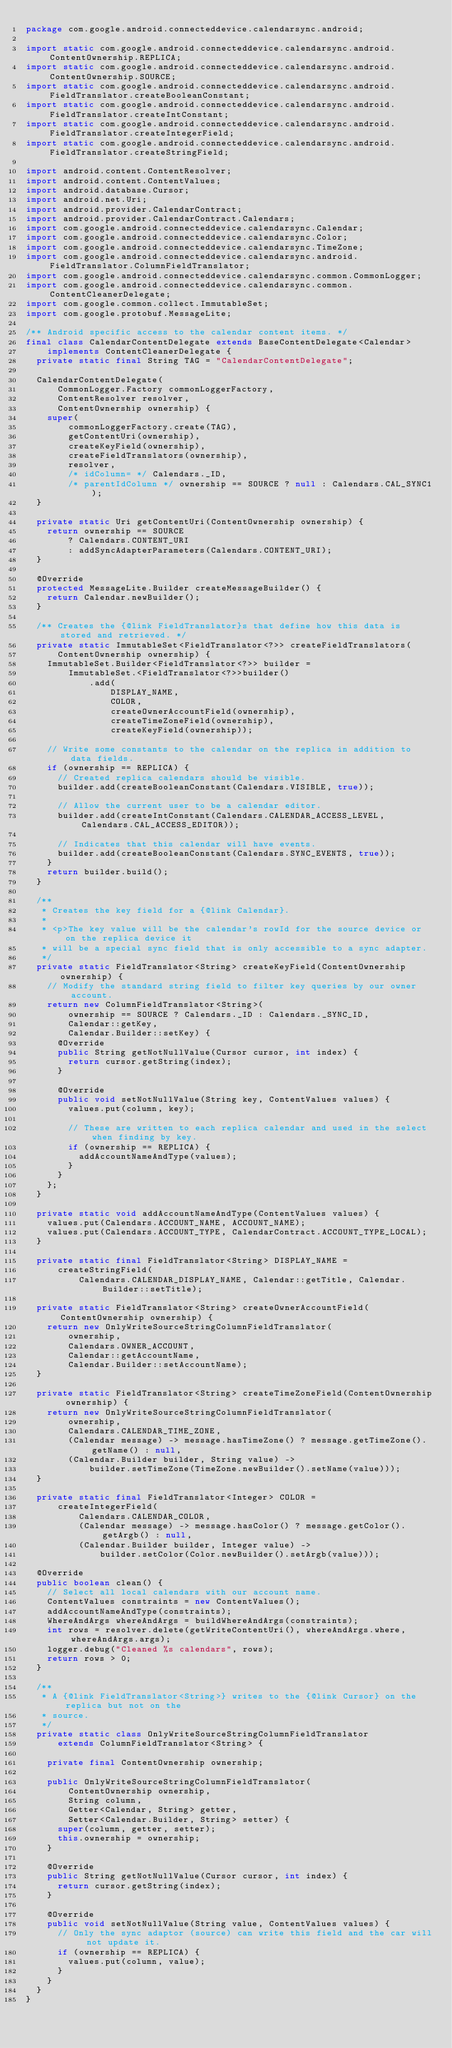Convert code to text. <code><loc_0><loc_0><loc_500><loc_500><_Java_>package com.google.android.connecteddevice.calendarsync.android;

import static com.google.android.connecteddevice.calendarsync.android.ContentOwnership.REPLICA;
import static com.google.android.connecteddevice.calendarsync.android.ContentOwnership.SOURCE;
import static com.google.android.connecteddevice.calendarsync.android.FieldTranslator.createBooleanConstant;
import static com.google.android.connecteddevice.calendarsync.android.FieldTranslator.createIntConstant;
import static com.google.android.connecteddevice.calendarsync.android.FieldTranslator.createIntegerField;
import static com.google.android.connecteddevice.calendarsync.android.FieldTranslator.createStringField;

import android.content.ContentResolver;
import android.content.ContentValues;
import android.database.Cursor;
import android.net.Uri;
import android.provider.CalendarContract;
import android.provider.CalendarContract.Calendars;
import com.google.android.connecteddevice.calendarsync.Calendar;
import com.google.android.connecteddevice.calendarsync.Color;
import com.google.android.connecteddevice.calendarsync.TimeZone;
import com.google.android.connecteddevice.calendarsync.android.FieldTranslator.ColumnFieldTranslator;
import com.google.android.connecteddevice.calendarsync.common.CommonLogger;
import com.google.android.connecteddevice.calendarsync.common.ContentCleanerDelegate;
import com.google.common.collect.ImmutableSet;
import com.google.protobuf.MessageLite;

/** Android specific access to the calendar content items. */
final class CalendarContentDelegate extends BaseContentDelegate<Calendar>
    implements ContentCleanerDelegate {
  private static final String TAG = "CalendarContentDelegate";

  CalendarContentDelegate(
      CommonLogger.Factory commonLoggerFactory,
      ContentResolver resolver,
      ContentOwnership ownership) {
    super(
        commonLoggerFactory.create(TAG),
        getContentUri(ownership),
        createKeyField(ownership),
        createFieldTranslators(ownership),
        resolver,
        /* idColumn= */ Calendars._ID,
        /* parentIdColumn */ ownership == SOURCE ? null : Calendars.CAL_SYNC1);
  }

  private static Uri getContentUri(ContentOwnership ownership) {
    return ownership == SOURCE
        ? Calendars.CONTENT_URI
        : addSyncAdapterParameters(Calendars.CONTENT_URI);
  }

  @Override
  protected MessageLite.Builder createMessageBuilder() {
    return Calendar.newBuilder();
  }

  /** Creates the {@link FieldTranslator}s that define how this data is stored and retrieved. */
  private static ImmutableSet<FieldTranslator<?>> createFieldTranslators(
      ContentOwnership ownership) {
    ImmutableSet.Builder<FieldTranslator<?>> builder =
        ImmutableSet.<FieldTranslator<?>>builder()
            .add(
                DISPLAY_NAME,
                COLOR,
                createOwnerAccountField(ownership),
                createTimeZoneField(ownership),
                createKeyField(ownership));

    // Write some constants to the calendar on the replica in addition to data fields.
    if (ownership == REPLICA) {
      // Created replica calendars should be visible.
      builder.add(createBooleanConstant(Calendars.VISIBLE, true));

      // Allow the current user to be a calendar editor.
      builder.add(createIntConstant(Calendars.CALENDAR_ACCESS_LEVEL, Calendars.CAL_ACCESS_EDITOR));

      // Indicates that this calendar will have events.
      builder.add(createBooleanConstant(Calendars.SYNC_EVENTS, true));
    }
    return builder.build();
  }

  /**
   * Creates the key field for a {@link Calendar}.
   *
   * <p>The key value will be the calendar's rowId for the source device or on the replica device it
   * will be a special sync field that is only accessible to a sync adapter.
   */
  private static FieldTranslator<String> createKeyField(ContentOwnership ownership) {
    // Modify the standard string field to filter key queries by our owner account.
    return new ColumnFieldTranslator<String>(
        ownership == SOURCE ? Calendars._ID : Calendars._SYNC_ID,
        Calendar::getKey,
        Calendar.Builder::setKey) {
      @Override
      public String getNotNullValue(Cursor cursor, int index) {
        return cursor.getString(index);
      }

      @Override
      public void setNotNullValue(String key, ContentValues values) {
        values.put(column, key);

        // These are written to each replica calendar and used in the select when finding by key.
        if (ownership == REPLICA) {
          addAccountNameAndType(values);
        }
      }
    };
  }

  private static void addAccountNameAndType(ContentValues values) {
    values.put(Calendars.ACCOUNT_NAME, ACCOUNT_NAME);
    values.put(Calendars.ACCOUNT_TYPE, CalendarContract.ACCOUNT_TYPE_LOCAL);
  }

  private static final FieldTranslator<String> DISPLAY_NAME =
      createStringField(
          Calendars.CALENDAR_DISPLAY_NAME, Calendar::getTitle, Calendar.Builder::setTitle);

  private static FieldTranslator<String> createOwnerAccountField(ContentOwnership ownership) {
    return new OnlyWriteSourceStringColumnFieldTranslator(
        ownership,
        Calendars.OWNER_ACCOUNT,
        Calendar::getAccountName,
        Calendar.Builder::setAccountName);
  }

  private static FieldTranslator<String> createTimeZoneField(ContentOwnership ownership) {
    return new OnlyWriteSourceStringColumnFieldTranslator(
        ownership,
        Calendars.CALENDAR_TIME_ZONE,
        (Calendar message) -> message.hasTimeZone() ? message.getTimeZone().getName() : null,
        (Calendar.Builder builder, String value) ->
            builder.setTimeZone(TimeZone.newBuilder().setName(value)));
  }

  private static final FieldTranslator<Integer> COLOR =
      createIntegerField(
          Calendars.CALENDAR_COLOR,
          (Calendar message) -> message.hasColor() ? message.getColor().getArgb() : null,
          (Calendar.Builder builder, Integer value) ->
              builder.setColor(Color.newBuilder().setArgb(value)));

  @Override
  public boolean clean() {
    // Select all local calendars with our account name.
    ContentValues constraints = new ContentValues();
    addAccountNameAndType(constraints);
    WhereAndArgs whereAndArgs = buildWhereAndArgs(constraints);
    int rows = resolver.delete(getWriteContentUri(), whereAndArgs.where, whereAndArgs.args);
    logger.debug("Cleaned %s calendars", rows);
    return rows > 0;
  }

  /**
   * A {@link FieldTranslator<String>} writes to the {@link Cursor} on the replica but not on the
   * source.
   */
  private static class OnlyWriteSourceStringColumnFieldTranslator
      extends ColumnFieldTranslator<String> {

    private final ContentOwnership ownership;

    public OnlyWriteSourceStringColumnFieldTranslator(
        ContentOwnership ownership,
        String column,
        Getter<Calendar, String> getter,
        Setter<Calendar.Builder, String> setter) {
      super(column, getter, setter);
      this.ownership = ownership;
    }

    @Override
    public String getNotNullValue(Cursor cursor, int index) {
      return cursor.getString(index);
    }

    @Override
    public void setNotNullValue(String value, ContentValues values) {
      // Only the sync adaptor (source) can write this field and the car will not update it.
      if (ownership == REPLICA) {
        values.put(column, value);
      }
    }
  }
}
</code> 